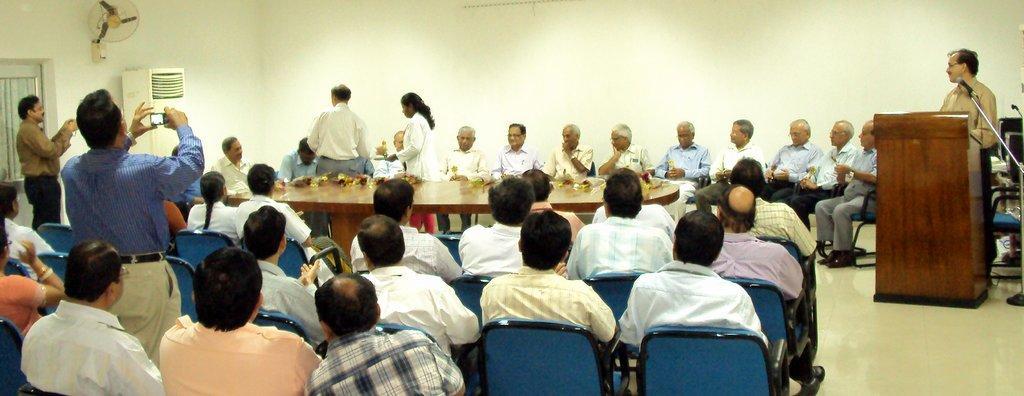Could you give a brief overview of what you see in this image? People are sitting on chairs. Few people are standing. In-front of this person there is a podium and mic. This man is holding a mobile. On this table there are things. In-front of this wall there is a portable air conditioner. Table fan is attached to the wall. This is curtain.   